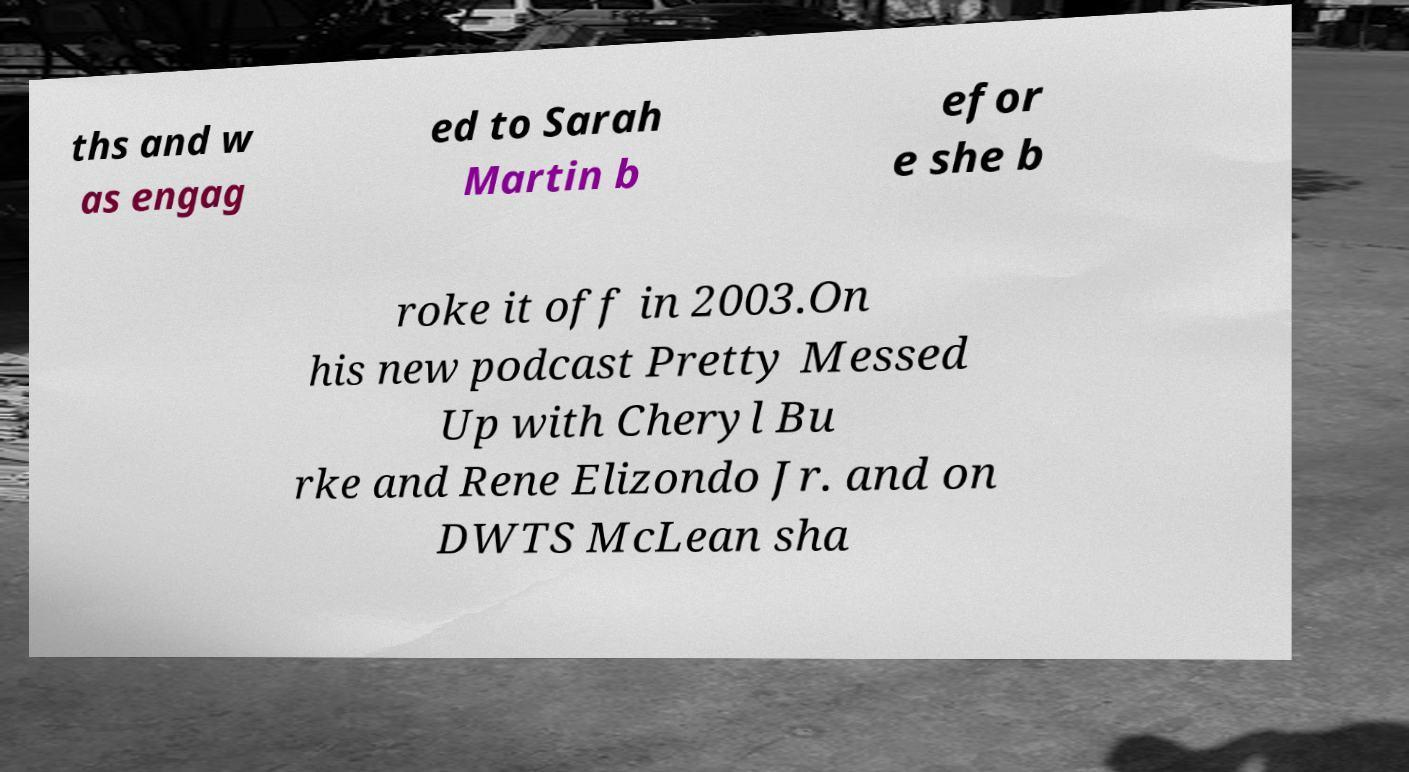Please identify and transcribe the text found in this image. ths and w as engag ed to Sarah Martin b efor e she b roke it off in 2003.On his new podcast Pretty Messed Up with Cheryl Bu rke and Rene Elizondo Jr. and on DWTS McLean sha 